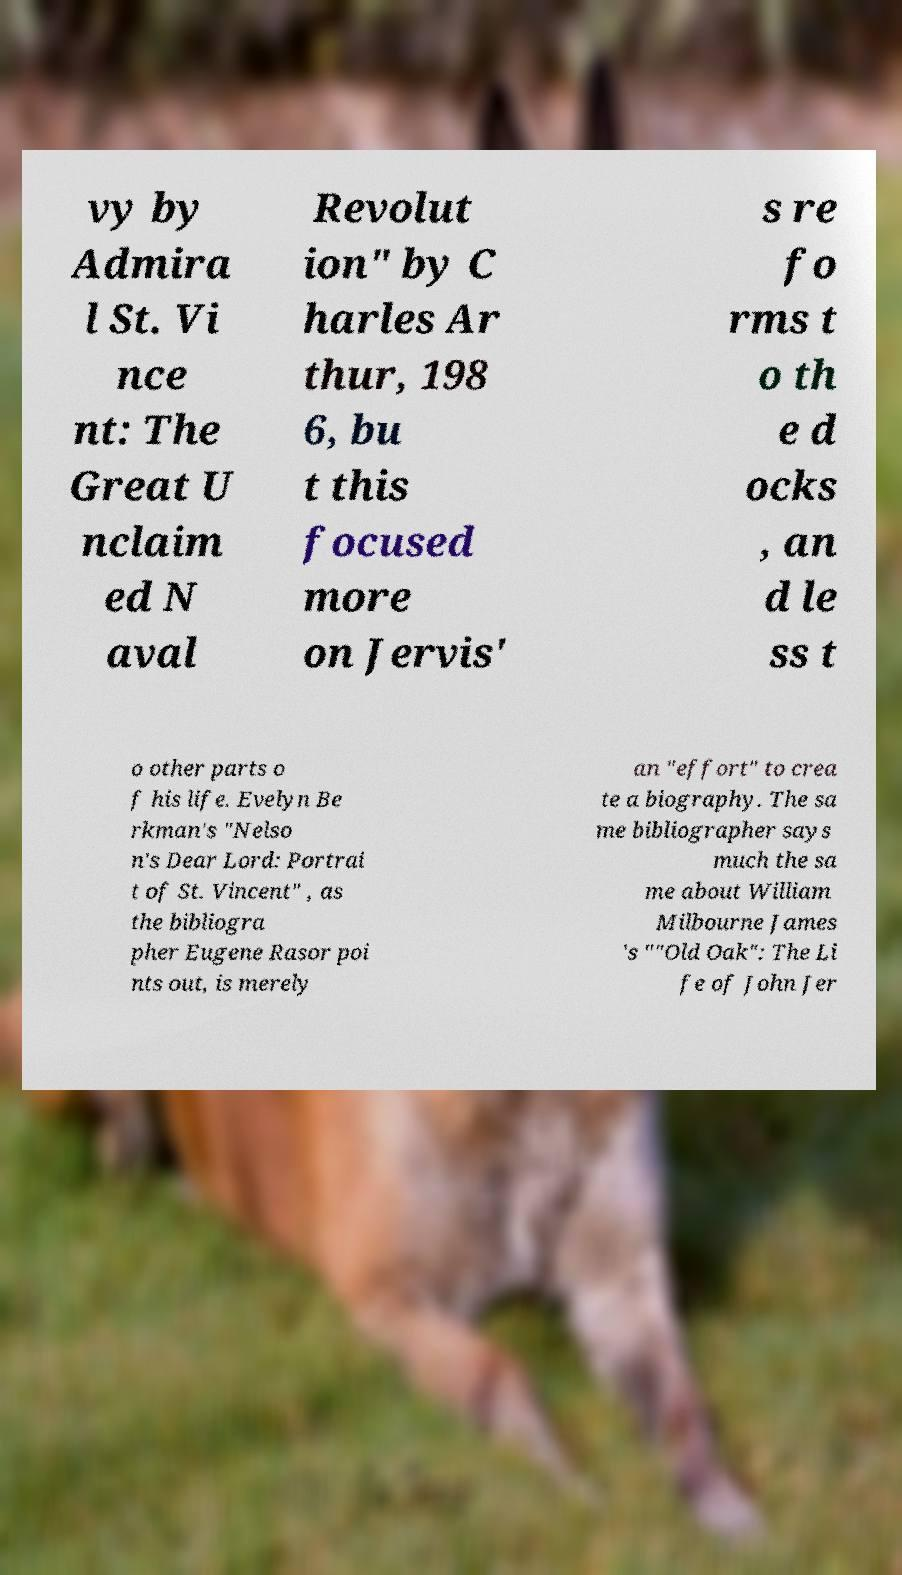Could you assist in decoding the text presented in this image and type it out clearly? vy by Admira l St. Vi nce nt: The Great U nclaim ed N aval Revolut ion" by C harles Ar thur, 198 6, bu t this focused more on Jervis' s re fo rms t o th e d ocks , an d le ss t o other parts o f his life. Evelyn Be rkman's "Nelso n's Dear Lord: Portrai t of St. Vincent" , as the bibliogra pher Eugene Rasor poi nts out, is merely an "effort" to crea te a biography. The sa me bibliographer says much the sa me about William Milbourne James 's ""Old Oak": The Li fe of John Jer 